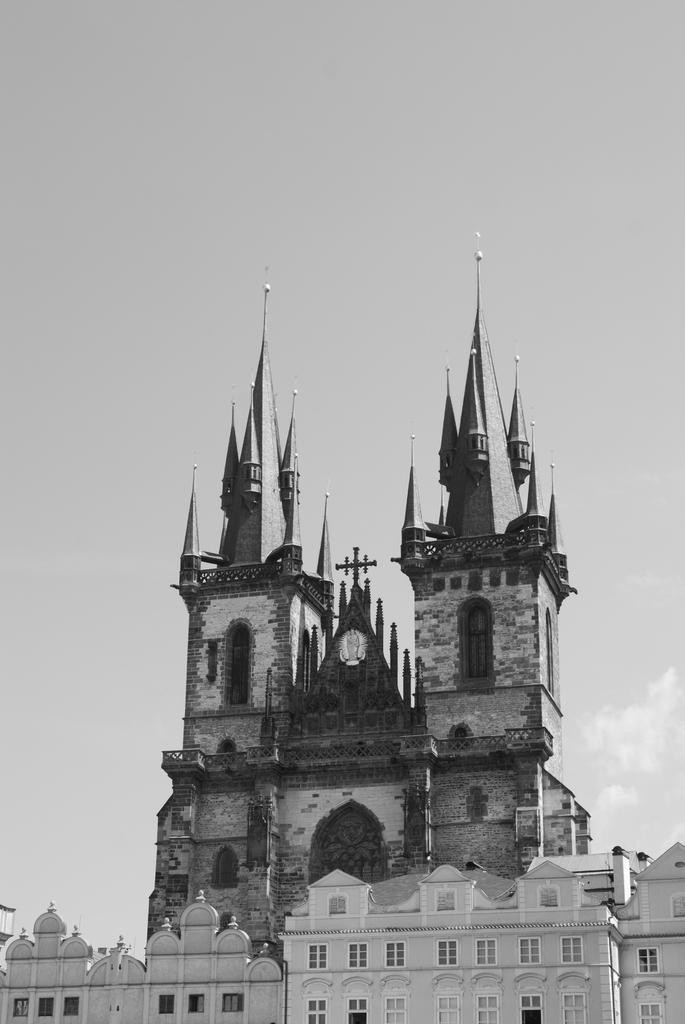How would you summarize this image in a sentence or two? At the bottom of the picture, there are buildings which are in white color. Behind that, we see a church. At the top of the picture, we see the sky and this picture is clicked outside the city. 